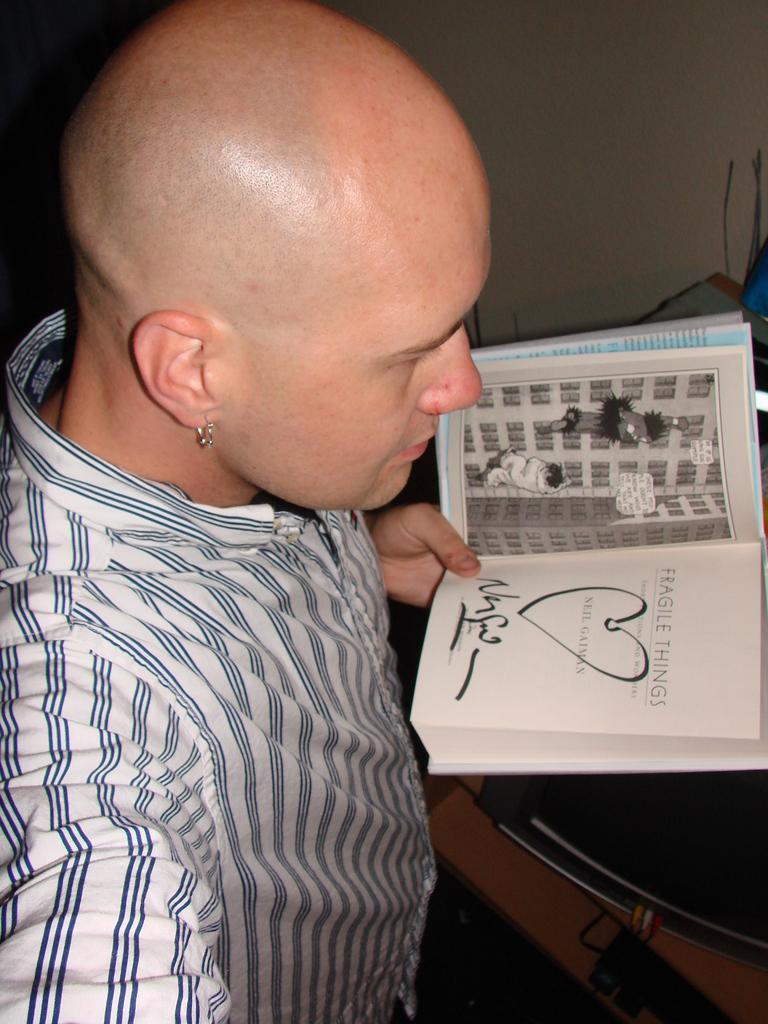How would you summarize this image in a sentence or two? In this image there is a person standing and holding a book in his hand and on the right side there is a table and on the table there is an object which is black in colour. 